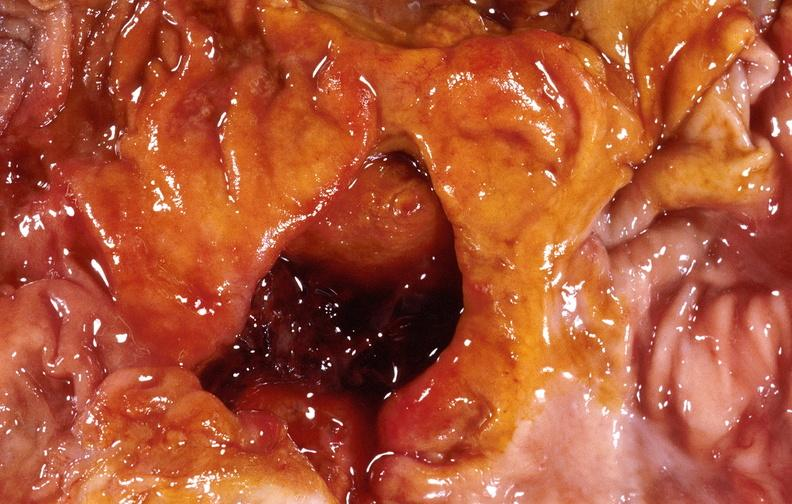s serous cystadenoma present?
Answer the question using a single word or phrase. No 